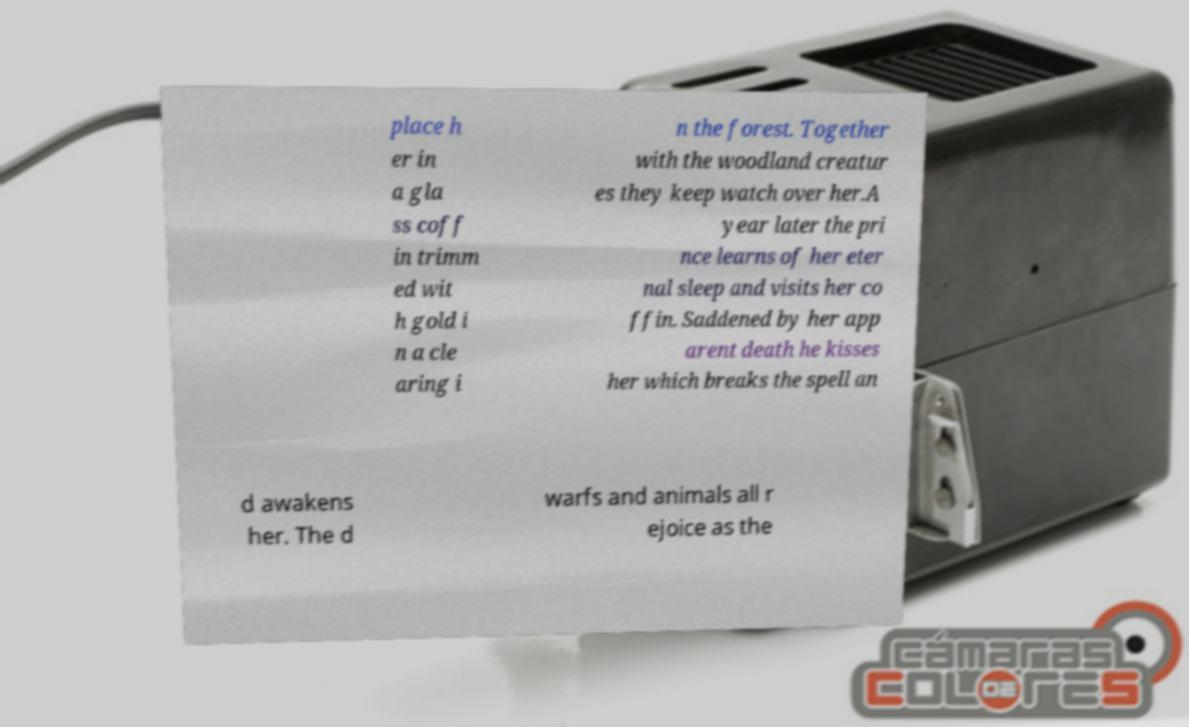Please identify and transcribe the text found in this image. place h er in a gla ss coff in trimm ed wit h gold i n a cle aring i n the forest. Together with the woodland creatur es they keep watch over her.A year later the pri nce learns of her eter nal sleep and visits her co ffin. Saddened by her app arent death he kisses her which breaks the spell an d awakens her. The d warfs and animals all r ejoice as the 